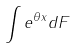Convert formula to latex. <formula><loc_0><loc_0><loc_500><loc_500>\int e ^ { \theta x } d F</formula> 